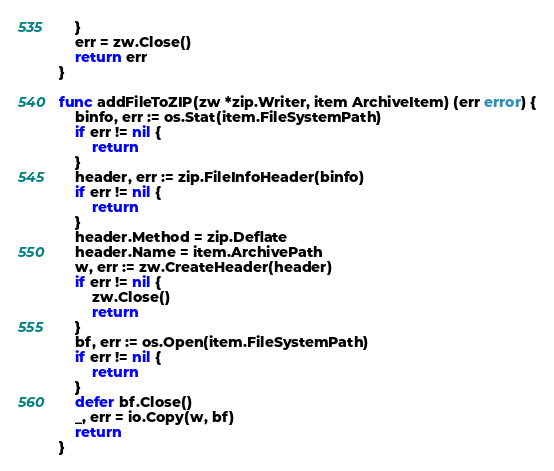<code> <loc_0><loc_0><loc_500><loc_500><_Go_>	}
	err = zw.Close()
	return err
}

func addFileToZIP(zw *zip.Writer, item ArchiveItem) (err error) {
	binfo, err := os.Stat(item.FileSystemPath)
	if err != nil {
		return
	}
	header, err := zip.FileInfoHeader(binfo)
	if err != nil {
		return
	}
	header.Method = zip.Deflate
	header.Name = item.ArchivePath
	w, err := zw.CreateHeader(header)
	if err != nil {
		zw.Close()
		return
	}
	bf, err := os.Open(item.FileSystemPath)
	if err != nil {
		return
	}
	defer bf.Close()
	_, err = io.Copy(w, bf)
	return
}
</code> 